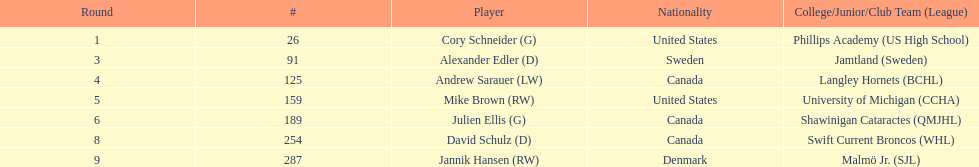How many players are from the united states? 2. 